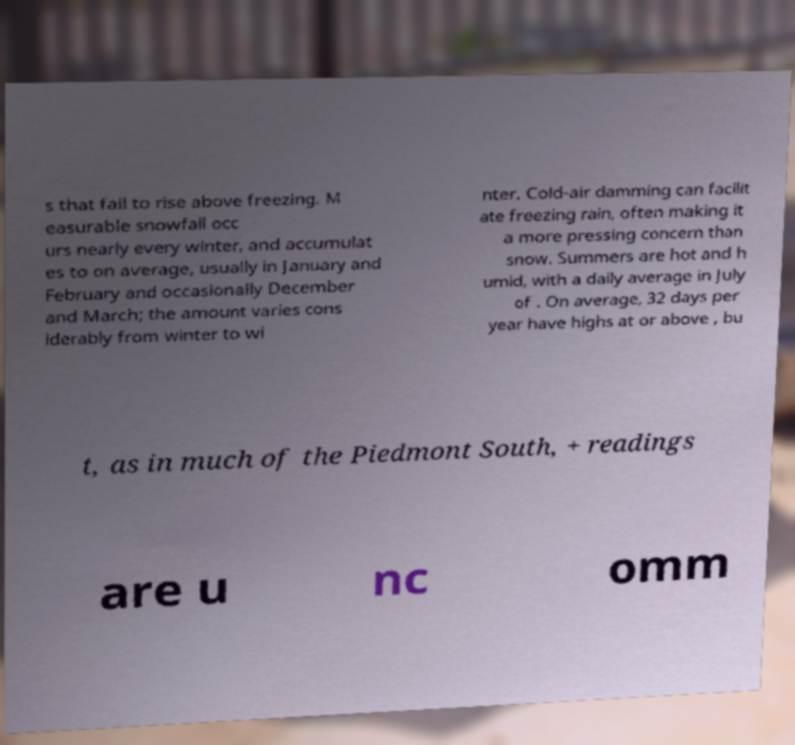There's text embedded in this image that I need extracted. Can you transcribe it verbatim? s that fail to rise above freezing. M easurable snowfall occ urs nearly every winter, and accumulat es to on average, usually in January and February and occasionally December and March; the amount varies cons iderably from winter to wi nter. Cold-air damming can facilit ate freezing rain, often making it a more pressing concern than snow. Summers are hot and h umid, with a daily average in July of . On average, 32 days per year have highs at or above , bu t, as in much of the Piedmont South, + readings are u nc omm 